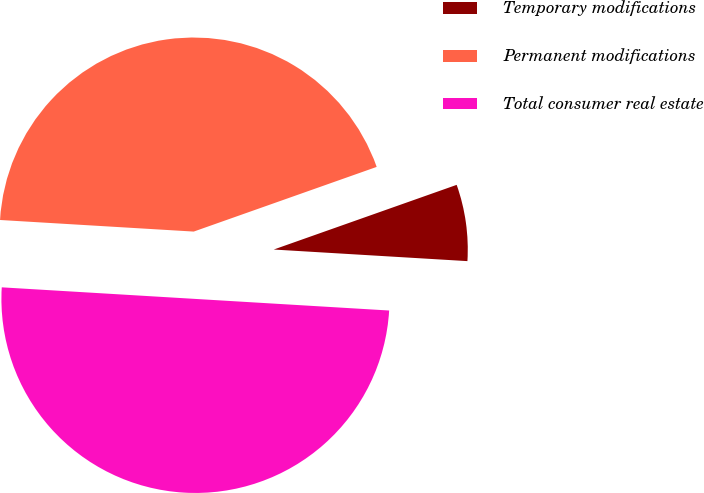Convert chart to OTSL. <chart><loc_0><loc_0><loc_500><loc_500><pie_chart><fcel>Temporary modifications<fcel>Permanent modifications<fcel>Total consumer real estate<nl><fcel>6.36%<fcel>43.64%<fcel>50.0%<nl></chart> 